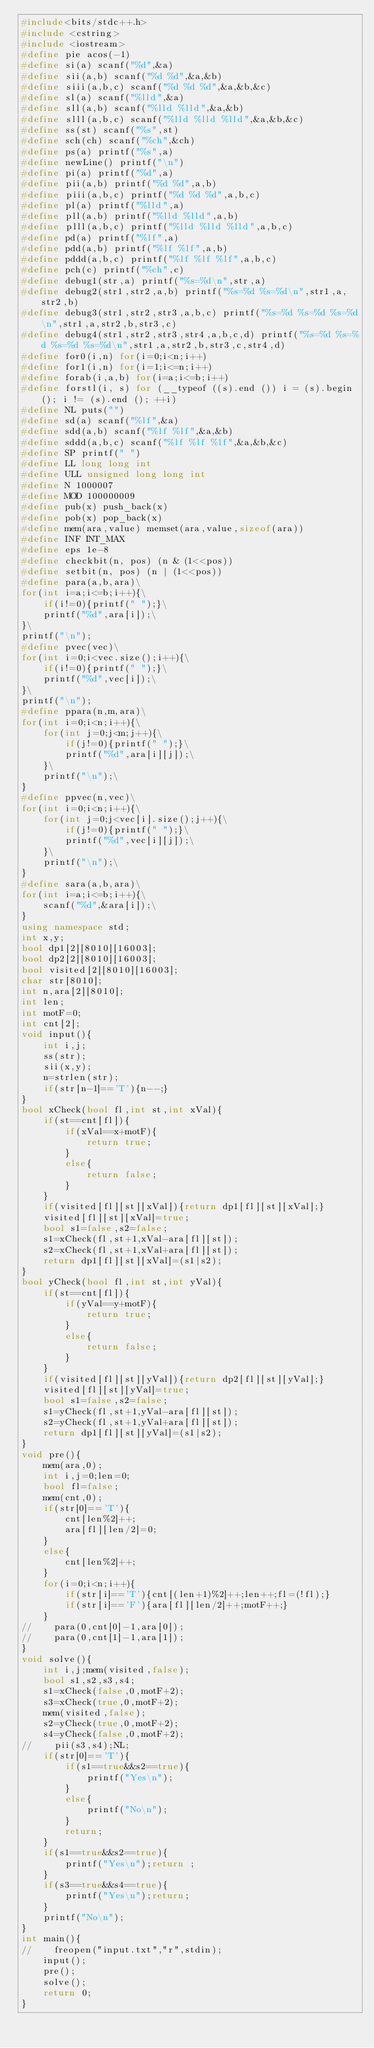Convert code to text. <code><loc_0><loc_0><loc_500><loc_500><_C++_>#include<bits/stdc++.h>
#include <cstring>
#include <iostream>
#define pie acos(-1)
#define si(a) scanf("%d",&a)
#define sii(a,b) scanf("%d %d",&a,&b)
#define siii(a,b,c) scanf("%d %d %d",&a,&b,&c)
#define sl(a) scanf("%lld",&a)
#define sll(a,b) scanf("%lld %lld",&a,&b)
#define slll(a,b,c) scanf("%lld %lld %lld",&a,&b,&c)
#define ss(st) scanf("%s",st)
#define sch(ch) scanf("%ch",&ch)
#define ps(a) printf("%s",a)
#define newLine() printf("\n")
#define pi(a) printf("%d",a)
#define pii(a,b) printf("%d %d",a,b)
#define piii(a,b,c) printf("%d %d %d",a,b,c)
#define pl(a) printf("%lld",a)
#define pll(a,b) printf("%lld %lld",a,b)
#define plll(a,b,c) printf("%lld %lld %lld",a,b,c)
#define pd(a) printf("%lf",a)
#define pdd(a,b) printf("%lf %lf",a,b)
#define pddd(a,b,c) printf("%lf %lf %lf",a,b,c)
#define pch(c) printf("%ch",c)
#define debug1(str,a) printf("%s=%d\n",str,a)
#define debug2(str1,str2,a,b) printf("%s=%d %s=%d\n",str1,a,str2,b)
#define debug3(str1,str2,str3,a,b,c) printf("%s=%d %s=%d %s=%d\n",str1,a,str2,b,str3,c)
#define debug4(str1,str2,str3,str4,a,b,c,d) printf("%s=%d %s=%d %s=%d %s=%d\n",str1,a,str2,b,str3,c,str4,d)
#define for0(i,n) for(i=0;i<n;i++)
#define for1(i,n) for(i=1;i<=n;i++)
#define forab(i,a,b) for(i=a;i<=b;i++)
#define forstl(i, s) for (__typeof ((s).end ()) i = (s).begin (); i != (s).end (); ++i)
#define NL puts("")
#define sd(a) scanf("%lf",&a)
#define sdd(a,b) scanf("%lf %lf",&a,&b)
#define sddd(a,b,c) scanf("%lf %lf %lf",&a,&b,&c)
#define SP printf(" ")
#define LL long long int
#define ULL unsigned long long int
#define N 1000007
#define MOD 100000009
#define pub(x) push_back(x)
#define pob(x) pop_back(x)
#define mem(ara,value) memset(ara,value,sizeof(ara))
#define INF INT_MAX
#define eps 1e-8
#define checkbit(n, pos) (n & (1<<pos))
#define setbit(n, pos) (n | (1<<pos))
#define para(a,b,ara)\
for(int i=a;i<=b;i++){\
    if(i!=0){printf(" ");}\
    printf("%d",ara[i]);\
}\
printf("\n");
#define pvec(vec)\
for(int i=0;i<vec.size();i++){\
    if(i!=0){printf(" ");}\
    printf("%d",vec[i]);\
}\
printf("\n");
#define ppara(n,m,ara)\
for(int i=0;i<n;i++){\
    for(int j=0;j<m;j++){\
        if(j!=0){printf(" ");}\
        printf("%d",ara[i][j]);\
    }\
    printf("\n");\
}
#define ppvec(n,vec)\
for(int i=0;i<n;i++){\
    for(int j=0;j<vec[i].size();j++){\
        if(j!=0){printf(" ");}\
        printf("%d",vec[i][j]);\
    }\
    printf("\n");\
}
#define sara(a,b,ara)\
for(int i=a;i<=b;i++){\
    scanf("%d",&ara[i]);\
}
using namespace std;
int x,y;
bool dp1[2][8010][16003];
bool dp2[2][8010][16003];
bool visited[2][8010][16003];
char str[8010];
int n,ara[2][8010];
int len;
int motF=0;
int cnt[2];
void input(){
    int i,j;
    ss(str);
    sii(x,y);
    n=strlen(str);
    if(str[n-1]=='T'){n--;}
}
bool xCheck(bool fl,int st,int xVal){
    if(st==cnt[fl]){
        if(xVal==x+motF){
            return true;
        }
        else{
            return false;
        }
    }
    if(visited[fl][st][xVal]){return dp1[fl][st][xVal];}
    visited[fl][st][xVal]=true;
    bool s1=false,s2=false;
    s1=xCheck(fl,st+1,xVal-ara[fl][st]);
    s2=xCheck(fl,st+1,xVal+ara[fl][st]);
    return dp1[fl][st][xVal]=(s1|s2);
}
bool yCheck(bool fl,int st,int yVal){
    if(st==cnt[fl]){
        if(yVal==y+motF){
            return true;
        }
        else{
            return false;
        }
    }
    if(visited[fl][st][yVal]){return dp2[fl][st][yVal];}
    visited[fl][st][yVal]=true;
    bool s1=false,s2=false;
    s1=yCheck(fl,st+1,yVal-ara[fl][st]);
    s2=yCheck(fl,st+1,yVal+ara[fl][st]);
    return dp1[fl][st][yVal]=(s1|s2);
}
void pre(){
    mem(ara,0);
    int i,j=0;len=0;
    bool fl=false;
    mem(cnt,0);
    if(str[0]=='T'){
        cnt[len%2]++;
        ara[fl][len/2]=0;
    }
    else{
        cnt[len%2]++;
    }
    for(i=0;i<n;i++){
        if(str[i]=='T'){cnt[(len+1)%2]++;len++;fl=(!fl);}
        if(str[i]=='F'){ara[fl][len/2]++;motF++;}
    }
//    para(0,cnt[0]-1,ara[0]);
//    para(0,cnt[1]-1,ara[1]);
}
void solve(){
    int i,j;mem(visited,false);
    bool s1,s2,s3,s4;
    s1=xCheck(false,0,motF+2);
    s3=xCheck(true,0,motF+2);
    mem(visited,false);
    s2=yCheck(true,0,motF+2);
    s4=yCheck(false,0,motF+2);
//    pii(s3,s4);NL;
    if(str[0]=='T'){
        if(s1==true&&s2==true){
            printf("Yes\n");
        }
        else{
            printf("No\n");
        }
        return;
    }
    if(s1==true&&s2==true){
        printf("Yes\n");return ;
    }
    if(s3==true&&s4==true){
        printf("Yes\n");return;
    }
    printf("No\n");
}
int main(){
//    freopen("input.txt","r",stdin);
    input();
    pre();
    solve();
    return 0;
}
</code> 